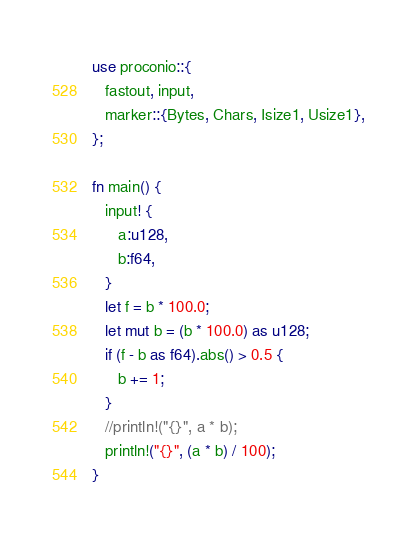Convert code to text. <code><loc_0><loc_0><loc_500><loc_500><_Rust_>use proconio::{
   fastout, input,
   marker::{Bytes, Chars, Isize1, Usize1},
};

fn main() {
   input! {
      a:u128,
      b:f64,
   }
   let f = b * 100.0;
   let mut b = (b * 100.0) as u128;
   if (f - b as f64).abs() > 0.5 {
      b += 1;
   }
   //println!("{}", a * b);
   println!("{}", (a * b) / 100);
}
</code> 